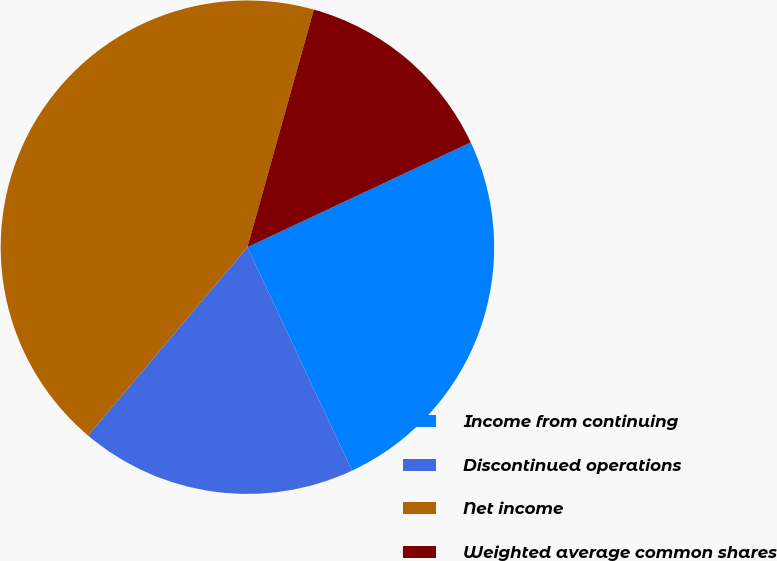Convert chart. <chart><loc_0><loc_0><loc_500><loc_500><pie_chart><fcel>Income from continuing<fcel>Discontinued operations<fcel>Net income<fcel>Weighted average common shares<nl><fcel>25.01%<fcel>18.15%<fcel>43.16%<fcel>13.68%<nl></chart> 